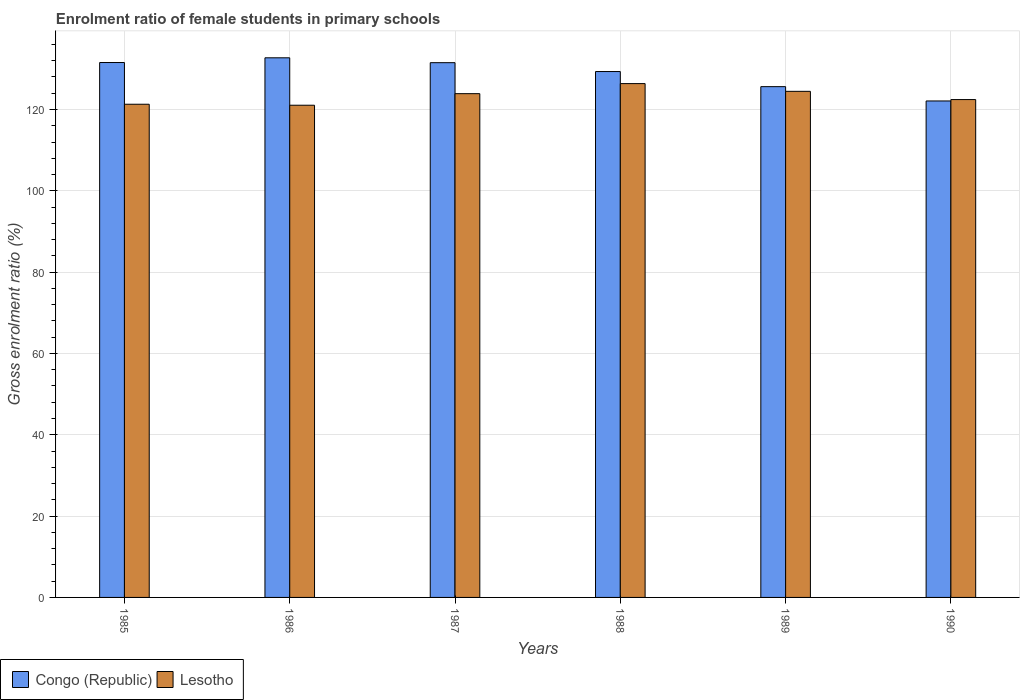Are the number of bars per tick equal to the number of legend labels?
Keep it short and to the point. Yes. Are the number of bars on each tick of the X-axis equal?
Ensure brevity in your answer.  Yes. How many bars are there on the 4th tick from the left?
Provide a succinct answer. 2. How many bars are there on the 5th tick from the right?
Offer a terse response. 2. What is the enrolment ratio of female students in primary schools in Lesotho in 1990?
Offer a very short reply. 122.45. Across all years, what is the maximum enrolment ratio of female students in primary schools in Congo (Republic)?
Offer a terse response. 132.72. Across all years, what is the minimum enrolment ratio of female students in primary schools in Congo (Republic)?
Your answer should be very brief. 122.1. In which year was the enrolment ratio of female students in primary schools in Congo (Republic) minimum?
Offer a terse response. 1990. What is the total enrolment ratio of female students in primary schools in Lesotho in the graph?
Ensure brevity in your answer.  739.54. What is the difference between the enrolment ratio of female students in primary schools in Lesotho in 1988 and that in 1990?
Provide a succinct answer. 3.93. What is the difference between the enrolment ratio of female students in primary schools in Congo (Republic) in 1989 and the enrolment ratio of female students in primary schools in Lesotho in 1990?
Your answer should be very brief. 3.18. What is the average enrolment ratio of female students in primary schools in Congo (Republic) per year?
Offer a terse response. 128.81. In the year 1986, what is the difference between the enrolment ratio of female students in primary schools in Congo (Republic) and enrolment ratio of female students in primary schools in Lesotho?
Your answer should be very brief. 11.66. What is the ratio of the enrolment ratio of female students in primary schools in Congo (Republic) in 1985 to that in 1990?
Offer a very short reply. 1.08. Is the enrolment ratio of female students in primary schools in Lesotho in 1989 less than that in 1990?
Offer a terse response. No. What is the difference between the highest and the second highest enrolment ratio of female students in primary schools in Congo (Republic)?
Your answer should be compact. 1.16. What is the difference between the highest and the lowest enrolment ratio of female students in primary schools in Lesotho?
Provide a succinct answer. 5.32. In how many years, is the enrolment ratio of female students in primary schools in Congo (Republic) greater than the average enrolment ratio of female students in primary schools in Congo (Republic) taken over all years?
Provide a short and direct response. 4. Is the sum of the enrolment ratio of female students in primary schools in Congo (Republic) in 1985 and 1986 greater than the maximum enrolment ratio of female students in primary schools in Lesotho across all years?
Provide a short and direct response. Yes. What does the 1st bar from the left in 1989 represents?
Give a very brief answer. Congo (Republic). What does the 1st bar from the right in 1988 represents?
Your answer should be very brief. Lesotho. How many bars are there?
Offer a terse response. 12. Are all the bars in the graph horizontal?
Offer a terse response. No. How many years are there in the graph?
Make the answer very short. 6. What is the difference between two consecutive major ticks on the Y-axis?
Give a very brief answer. 20. Does the graph contain any zero values?
Offer a terse response. No. Where does the legend appear in the graph?
Your answer should be compact. Bottom left. How many legend labels are there?
Your answer should be very brief. 2. How are the legend labels stacked?
Your answer should be very brief. Horizontal. What is the title of the graph?
Your answer should be very brief. Enrolment ratio of female students in primary schools. Does "North America" appear as one of the legend labels in the graph?
Provide a short and direct response. No. What is the Gross enrolment ratio (%) of Congo (Republic) in 1985?
Provide a succinct answer. 131.56. What is the Gross enrolment ratio (%) in Lesotho in 1985?
Make the answer very short. 121.3. What is the Gross enrolment ratio (%) of Congo (Republic) in 1986?
Keep it short and to the point. 132.72. What is the Gross enrolment ratio (%) of Lesotho in 1986?
Your answer should be compact. 121.05. What is the Gross enrolment ratio (%) in Congo (Republic) in 1987?
Offer a very short reply. 131.52. What is the Gross enrolment ratio (%) in Lesotho in 1987?
Your answer should be compact. 123.9. What is the Gross enrolment ratio (%) of Congo (Republic) in 1988?
Your response must be concise. 129.34. What is the Gross enrolment ratio (%) of Lesotho in 1988?
Give a very brief answer. 126.37. What is the Gross enrolment ratio (%) of Congo (Republic) in 1989?
Ensure brevity in your answer.  125.62. What is the Gross enrolment ratio (%) in Lesotho in 1989?
Offer a terse response. 124.47. What is the Gross enrolment ratio (%) in Congo (Republic) in 1990?
Provide a succinct answer. 122.1. What is the Gross enrolment ratio (%) of Lesotho in 1990?
Provide a short and direct response. 122.45. Across all years, what is the maximum Gross enrolment ratio (%) in Congo (Republic)?
Provide a short and direct response. 132.72. Across all years, what is the maximum Gross enrolment ratio (%) of Lesotho?
Your response must be concise. 126.37. Across all years, what is the minimum Gross enrolment ratio (%) in Congo (Republic)?
Give a very brief answer. 122.1. Across all years, what is the minimum Gross enrolment ratio (%) in Lesotho?
Ensure brevity in your answer.  121.05. What is the total Gross enrolment ratio (%) of Congo (Republic) in the graph?
Provide a succinct answer. 772.86. What is the total Gross enrolment ratio (%) in Lesotho in the graph?
Ensure brevity in your answer.  739.54. What is the difference between the Gross enrolment ratio (%) of Congo (Republic) in 1985 and that in 1986?
Provide a succinct answer. -1.16. What is the difference between the Gross enrolment ratio (%) in Lesotho in 1985 and that in 1986?
Your answer should be compact. 0.24. What is the difference between the Gross enrolment ratio (%) in Congo (Republic) in 1985 and that in 1987?
Give a very brief answer. 0.04. What is the difference between the Gross enrolment ratio (%) in Lesotho in 1985 and that in 1987?
Provide a succinct answer. -2.6. What is the difference between the Gross enrolment ratio (%) of Congo (Republic) in 1985 and that in 1988?
Ensure brevity in your answer.  2.22. What is the difference between the Gross enrolment ratio (%) in Lesotho in 1985 and that in 1988?
Offer a very short reply. -5.08. What is the difference between the Gross enrolment ratio (%) in Congo (Republic) in 1985 and that in 1989?
Provide a short and direct response. 5.93. What is the difference between the Gross enrolment ratio (%) in Lesotho in 1985 and that in 1989?
Offer a terse response. -3.18. What is the difference between the Gross enrolment ratio (%) in Congo (Republic) in 1985 and that in 1990?
Your response must be concise. 9.45. What is the difference between the Gross enrolment ratio (%) in Lesotho in 1985 and that in 1990?
Your answer should be compact. -1.15. What is the difference between the Gross enrolment ratio (%) of Congo (Republic) in 1986 and that in 1987?
Offer a very short reply. 1.2. What is the difference between the Gross enrolment ratio (%) of Lesotho in 1986 and that in 1987?
Your answer should be very brief. -2.84. What is the difference between the Gross enrolment ratio (%) in Congo (Republic) in 1986 and that in 1988?
Give a very brief answer. 3.38. What is the difference between the Gross enrolment ratio (%) in Lesotho in 1986 and that in 1988?
Your answer should be compact. -5.32. What is the difference between the Gross enrolment ratio (%) of Congo (Republic) in 1986 and that in 1989?
Your response must be concise. 7.09. What is the difference between the Gross enrolment ratio (%) of Lesotho in 1986 and that in 1989?
Make the answer very short. -3.42. What is the difference between the Gross enrolment ratio (%) in Congo (Republic) in 1986 and that in 1990?
Your response must be concise. 10.61. What is the difference between the Gross enrolment ratio (%) in Lesotho in 1986 and that in 1990?
Offer a terse response. -1.39. What is the difference between the Gross enrolment ratio (%) of Congo (Republic) in 1987 and that in 1988?
Provide a short and direct response. 2.18. What is the difference between the Gross enrolment ratio (%) in Lesotho in 1987 and that in 1988?
Make the answer very short. -2.48. What is the difference between the Gross enrolment ratio (%) in Congo (Republic) in 1987 and that in 1989?
Offer a very short reply. 5.89. What is the difference between the Gross enrolment ratio (%) of Lesotho in 1987 and that in 1989?
Your answer should be very brief. -0.57. What is the difference between the Gross enrolment ratio (%) in Congo (Republic) in 1987 and that in 1990?
Make the answer very short. 9.41. What is the difference between the Gross enrolment ratio (%) of Lesotho in 1987 and that in 1990?
Provide a succinct answer. 1.45. What is the difference between the Gross enrolment ratio (%) of Congo (Republic) in 1988 and that in 1989?
Ensure brevity in your answer.  3.72. What is the difference between the Gross enrolment ratio (%) in Lesotho in 1988 and that in 1989?
Give a very brief answer. 1.9. What is the difference between the Gross enrolment ratio (%) in Congo (Republic) in 1988 and that in 1990?
Your response must be concise. 7.24. What is the difference between the Gross enrolment ratio (%) of Lesotho in 1988 and that in 1990?
Offer a terse response. 3.93. What is the difference between the Gross enrolment ratio (%) in Congo (Republic) in 1989 and that in 1990?
Provide a succinct answer. 3.52. What is the difference between the Gross enrolment ratio (%) in Lesotho in 1989 and that in 1990?
Ensure brevity in your answer.  2.03. What is the difference between the Gross enrolment ratio (%) of Congo (Republic) in 1985 and the Gross enrolment ratio (%) of Lesotho in 1986?
Your response must be concise. 10.5. What is the difference between the Gross enrolment ratio (%) in Congo (Republic) in 1985 and the Gross enrolment ratio (%) in Lesotho in 1987?
Your response must be concise. 7.66. What is the difference between the Gross enrolment ratio (%) in Congo (Republic) in 1985 and the Gross enrolment ratio (%) in Lesotho in 1988?
Your answer should be very brief. 5.18. What is the difference between the Gross enrolment ratio (%) of Congo (Republic) in 1985 and the Gross enrolment ratio (%) of Lesotho in 1989?
Your answer should be compact. 7.08. What is the difference between the Gross enrolment ratio (%) in Congo (Republic) in 1985 and the Gross enrolment ratio (%) in Lesotho in 1990?
Give a very brief answer. 9.11. What is the difference between the Gross enrolment ratio (%) of Congo (Republic) in 1986 and the Gross enrolment ratio (%) of Lesotho in 1987?
Offer a terse response. 8.82. What is the difference between the Gross enrolment ratio (%) in Congo (Republic) in 1986 and the Gross enrolment ratio (%) in Lesotho in 1988?
Keep it short and to the point. 6.34. What is the difference between the Gross enrolment ratio (%) in Congo (Republic) in 1986 and the Gross enrolment ratio (%) in Lesotho in 1989?
Offer a terse response. 8.24. What is the difference between the Gross enrolment ratio (%) in Congo (Republic) in 1986 and the Gross enrolment ratio (%) in Lesotho in 1990?
Keep it short and to the point. 10.27. What is the difference between the Gross enrolment ratio (%) in Congo (Republic) in 1987 and the Gross enrolment ratio (%) in Lesotho in 1988?
Give a very brief answer. 5.14. What is the difference between the Gross enrolment ratio (%) in Congo (Republic) in 1987 and the Gross enrolment ratio (%) in Lesotho in 1989?
Your response must be concise. 7.05. What is the difference between the Gross enrolment ratio (%) in Congo (Republic) in 1987 and the Gross enrolment ratio (%) in Lesotho in 1990?
Your answer should be compact. 9.07. What is the difference between the Gross enrolment ratio (%) of Congo (Republic) in 1988 and the Gross enrolment ratio (%) of Lesotho in 1989?
Your response must be concise. 4.87. What is the difference between the Gross enrolment ratio (%) in Congo (Republic) in 1988 and the Gross enrolment ratio (%) in Lesotho in 1990?
Provide a short and direct response. 6.89. What is the difference between the Gross enrolment ratio (%) of Congo (Republic) in 1989 and the Gross enrolment ratio (%) of Lesotho in 1990?
Provide a succinct answer. 3.18. What is the average Gross enrolment ratio (%) of Congo (Republic) per year?
Offer a very short reply. 128.81. What is the average Gross enrolment ratio (%) of Lesotho per year?
Your answer should be very brief. 123.26. In the year 1985, what is the difference between the Gross enrolment ratio (%) in Congo (Republic) and Gross enrolment ratio (%) in Lesotho?
Provide a short and direct response. 10.26. In the year 1986, what is the difference between the Gross enrolment ratio (%) of Congo (Republic) and Gross enrolment ratio (%) of Lesotho?
Ensure brevity in your answer.  11.66. In the year 1987, what is the difference between the Gross enrolment ratio (%) in Congo (Republic) and Gross enrolment ratio (%) in Lesotho?
Make the answer very short. 7.62. In the year 1988, what is the difference between the Gross enrolment ratio (%) of Congo (Republic) and Gross enrolment ratio (%) of Lesotho?
Your response must be concise. 2.97. In the year 1989, what is the difference between the Gross enrolment ratio (%) of Congo (Republic) and Gross enrolment ratio (%) of Lesotho?
Make the answer very short. 1.15. In the year 1990, what is the difference between the Gross enrolment ratio (%) of Congo (Republic) and Gross enrolment ratio (%) of Lesotho?
Give a very brief answer. -0.34. What is the ratio of the Gross enrolment ratio (%) in Congo (Republic) in 1985 to that in 1986?
Your answer should be very brief. 0.99. What is the ratio of the Gross enrolment ratio (%) in Congo (Republic) in 1985 to that in 1987?
Offer a terse response. 1. What is the ratio of the Gross enrolment ratio (%) in Congo (Republic) in 1985 to that in 1988?
Keep it short and to the point. 1.02. What is the ratio of the Gross enrolment ratio (%) of Lesotho in 1985 to that in 1988?
Your answer should be very brief. 0.96. What is the ratio of the Gross enrolment ratio (%) of Congo (Republic) in 1985 to that in 1989?
Your answer should be very brief. 1.05. What is the ratio of the Gross enrolment ratio (%) in Lesotho in 1985 to that in 1989?
Provide a short and direct response. 0.97. What is the ratio of the Gross enrolment ratio (%) in Congo (Republic) in 1985 to that in 1990?
Make the answer very short. 1.08. What is the ratio of the Gross enrolment ratio (%) in Lesotho in 1985 to that in 1990?
Make the answer very short. 0.99. What is the ratio of the Gross enrolment ratio (%) in Congo (Republic) in 1986 to that in 1987?
Give a very brief answer. 1.01. What is the ratio of the Gross enrolment ratio (%) of Lesotho in 1986 to that in 1987?
Your answer should be very brief. 0.98. What is the ratio of the Gross enrolment ratio (%) of Congo (Republic) in 1986 to that in 1988?
Make the answer very short. 1.03. What is the ratio of the Gross enrolment ratio (%) of Lesotho in 1986 to that in 1988?
Ensure brevity in your answer.  0.96. What is the ratio of the Gross enrolment ratio (%) of Congo (Republic) in 1986 to that in 1989?
Your answer should be very brief. 1.06. What is the ratio of the Gross enrolment ratio (%) in Lesotho in 1986 to that in 1989?
Your answer should be compact. 0.97. What is the ratio of the Gross enrolment ratio (%) in Congo (Republic) in 1986 to that in 1990?
Provide a succinct answer. 1.09. What is the ratio of the Gross enrolment ratio (%) of Congo (Republic) in 1987 to that in 1988?
Ensure brevity in your answer.  1.02. What is the ratio of the Gross enrolment ratio (%) of Lesotho in 1987 to that in 1988?
Keep it short and to the point. 0.98. What is the ratio of the Gross enrolment ratio (%) of Congo (Republic) in 1987 to that in 1989?
Your answer should be very brief. 1.05. What is the ratio of the Gross enrolment ratio (%) in Lesotho in 1987 to that in 1989?
Provide a short and direct response. 1. What is the ratio of the Gross enrolment ratio (%) in Congo (Republic) in 1987 to that in 1990?
Provide a succinct answer. 1.08. What is the ratio of the Gross enrolment ratio (%) in Lesotho in 1987 to that in 1990?
Make the answer very short. 1.01. What is the ratio of the Gross enrolment ratio (%) in Congo (Republic) in 1988 to that in 1989?
Keep it short and to the point. 1.03. What is the ratio of the Gross enrolment ratio (%) of Lesotho in 1988 to that in 1989?
Provide a short and direct response. 1.02. What is the ratio of the Gross enrolment ratio (%) in Congo (Republic) in 1988 to that in 1990?
Your response must be concise. 1.06. What is the ratio of the Gross enrolment ratio (%) in Lesotho in 1988 to that in 1990?
Your answer should be very brief. 1.03. What is the ratio of the Gross enrolment ratio (%) in Congo (Republic) in 1989 to that in 1990?
Make the answer very short. 1.03. What is the ratio of the Gross enrolment ratio (%) in Lesotho in 1989 to that in 1990?
Provide a succinct answer. 1.02. What is the difference between the highest and the second highest Gross enrolment ratio (%) of Congo (Republic)?
Keep it short and to the point. 1.16. What is the difference between the highest and the second highest Gross enrolment ratio (%) of Lesotho?
Give a very brief answer. 1.9. What is the difference between the highest and the lowest Gross enrolment ratio (%) of Congo (Republic)?
Give a very brief answer. 10.61. What is the difference between the highest and the lowest Gross enrolment ratio (%) in Lesotho?
Offer a very short reply. 5.32. 